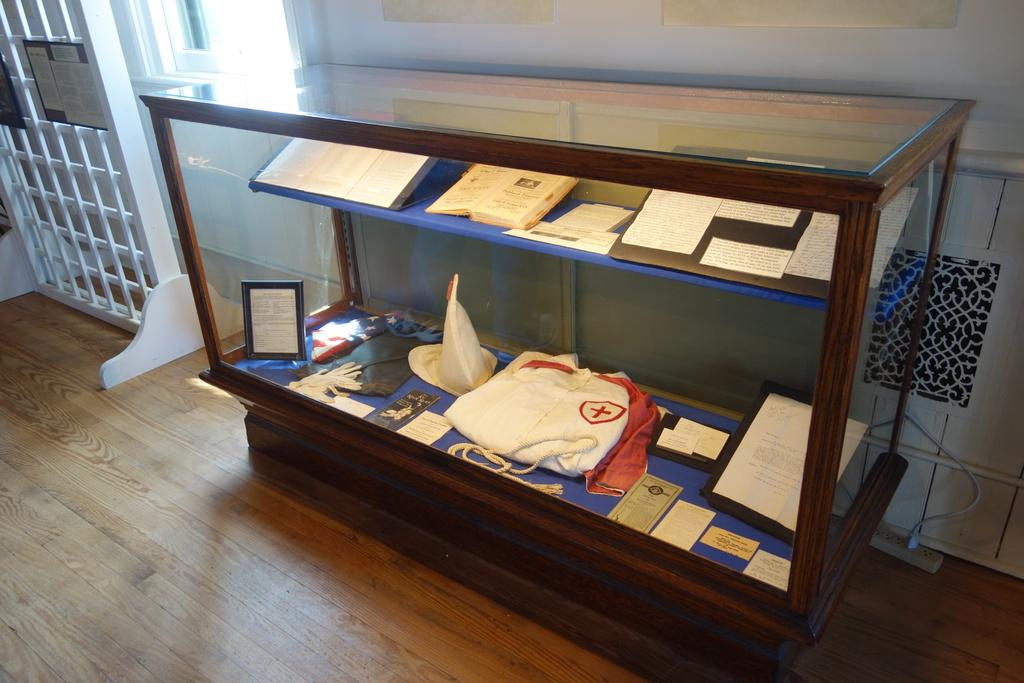What type of furniture is present in the image? There is a cupboard in the image. What is placed in front of the cupboard? The cupboard has many things in front of it. Where is the cupboard positioned in the image? The cupboard is placed against a wall. What other architectural feature is visible in the image? There is a gate beside the cupboard. How does the business of cork production relate to the image? There is no mention of cork or any business in the image, so it is not possible to establish a connection between the image and cork production. 